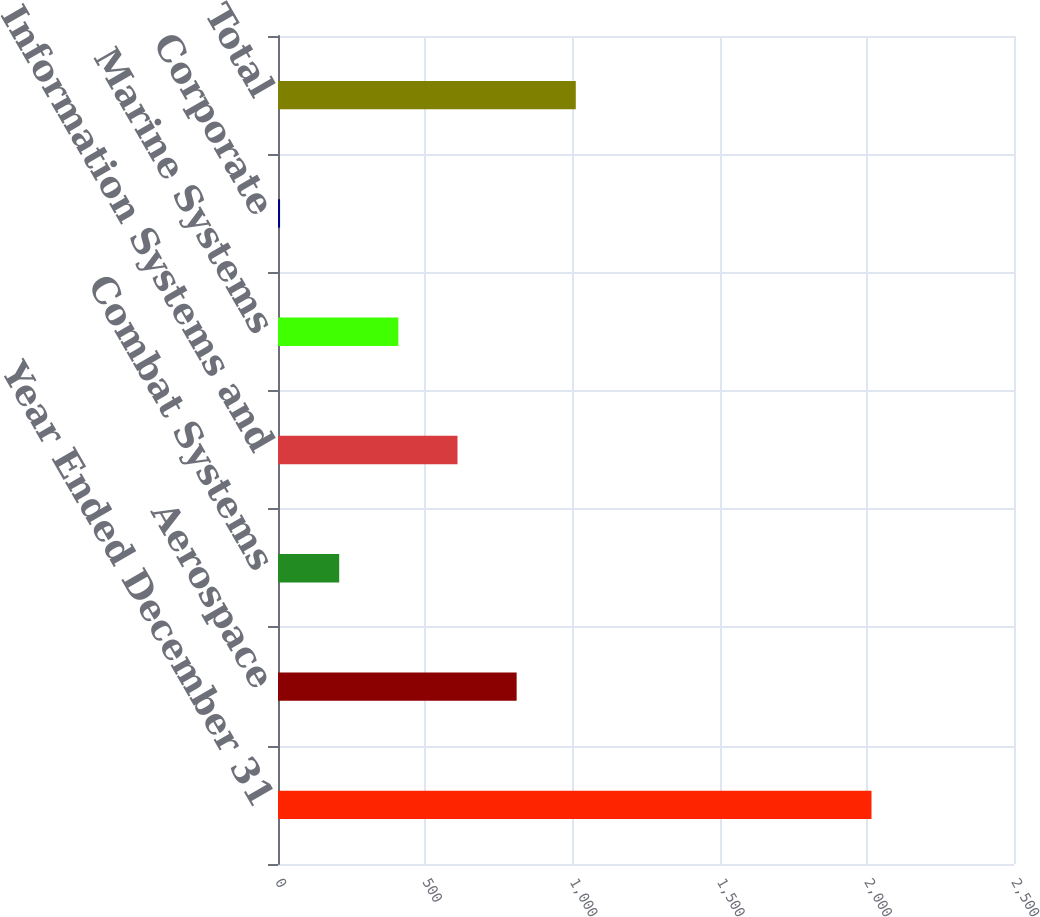Convert chart to OTSL. <chart><loc_0><loc_0><loc_500><loc_500><bar_chart><fcel>Year Ended December 31<fcel>Aerospace<fcel>Combat Systems<fcel>Information Systems and<fcel>Marine Systems<fcel>Corporate<fcel>Total<nl><fcel>2016<fcel>810.6<fcel>207.9<fcel>609.7<fcel>408.8<fcel>7<fcel>1011.5<nl></chart> 